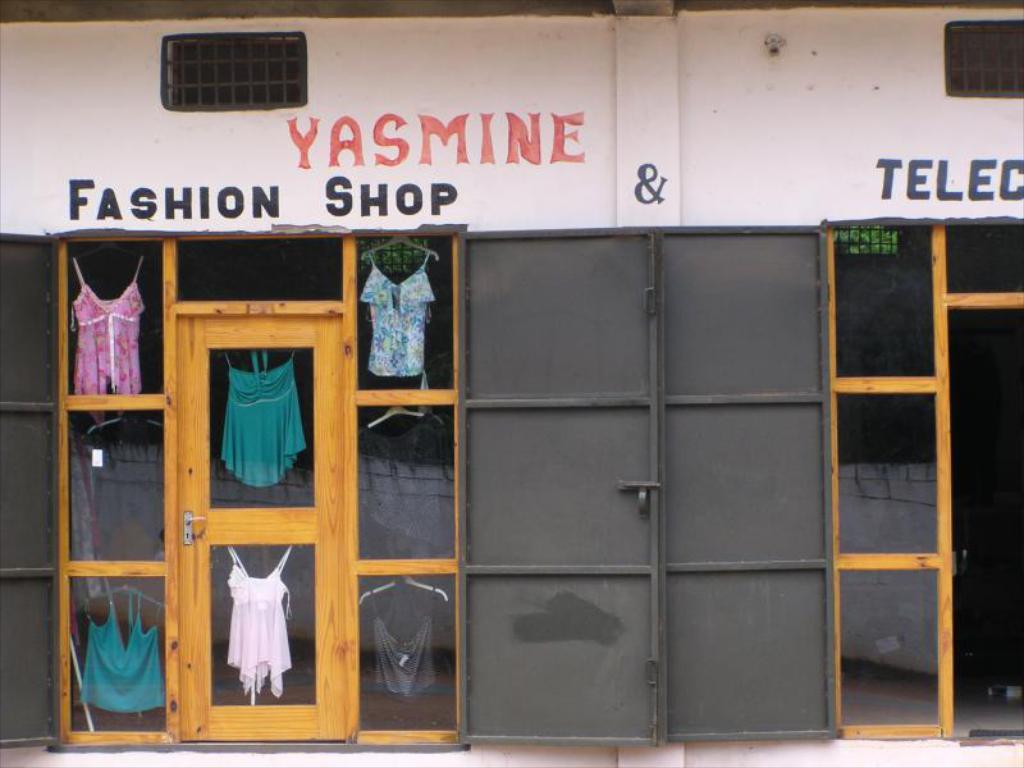What is the name in red?
Keep it short and to the point. Yasmine. What type of shop is this?
Your response must be concise. Fashion. 